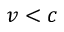Convert formula to latex. <formula><loc_0><loc_0><loc_500><loc_500>v < c</formula> 